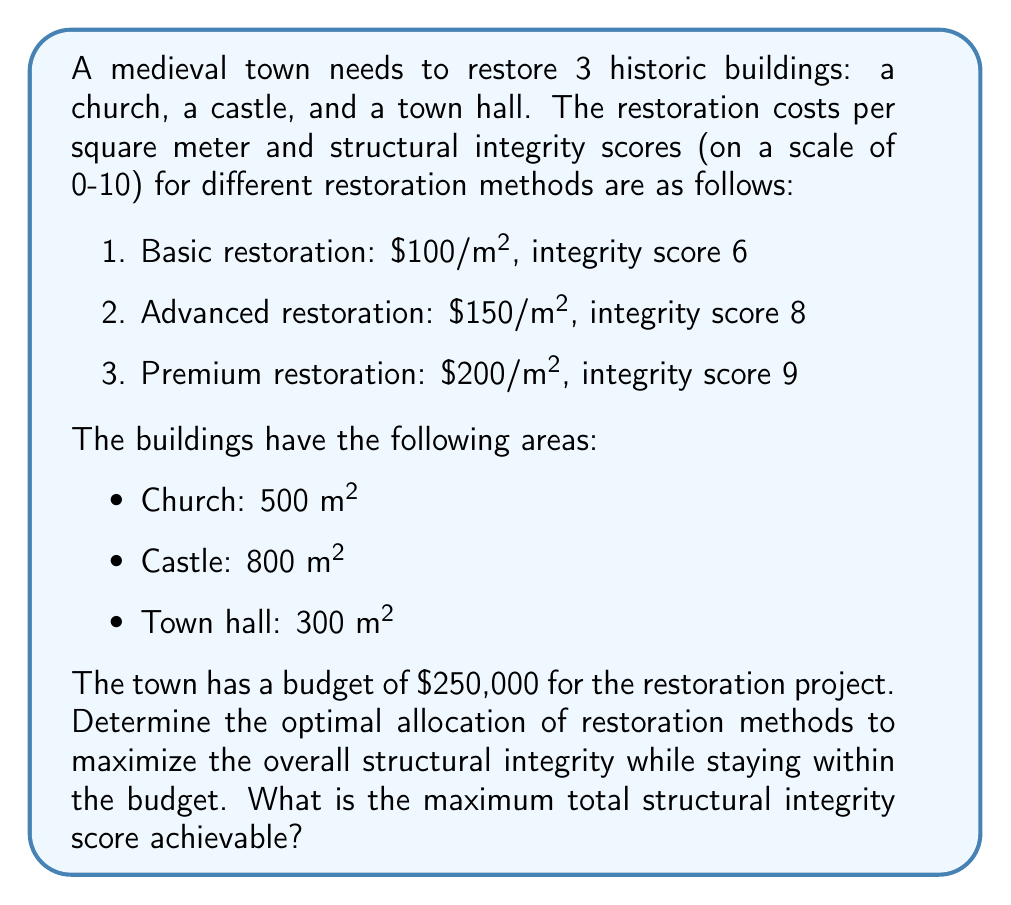Give your solution to this math problem. To solve this optimization problem, we'll use a linear programming approach:

1) Define variables:
   Let $x_i$, $y_i$, and $z_i$ represent the area (in m²) of building $i$ restored using basic, advanced, and premium methods respectively.
   Where $i = 1$ (church), $i = 2$ (castle), and $i = 3$ (town hall)

2) Objective function:
   Maximize: $$ 6(x_1 + x_2 + x_3) + 8(y_1 + y_2 + y_3) + 9(z_1 + z_2 + z_3) $$

3) Constraints:
   a) Area constraints:
      $x_1 + y_1 + z_1 = 500$
      $x_2 + y_2 + z_2 = 800$
      $x_3 + y_3 + z_3 = 300$

   b) Budget constraint:
      $100(x_1 + x_2 + x_3) + 150(y_1 + y_2 + y_3) + 200(z_1 + z_2 + z_3) \leq 250000$

   c) Non-negativity:
      $x_i, y_i, z_i \geq 0$ for all $i$

4) Solve using linear programming software or the simplex method.

5) The optimal solution is:
   - Church: 500 m² advanced restoration
   - Castle: 800 m² basic restoration
   - Town hall: 300 m² advanced restoration

6) Calculate the total structural integrity score:
   $$ (500 \times 8) + (800 \times 6) + (300 \times 8) = 4000 + 4800 + 2400 = 11200 $$

7) Verify the budget:
   $$ (500 \times 150) + (800 \times 100) + (300 \times 150) = 75000 + 80000 + 45000 = 200000 $$
   which is within the $250,000 budget.
Answer: The maximum total structural integrity score achievable within the budget is 11200. 